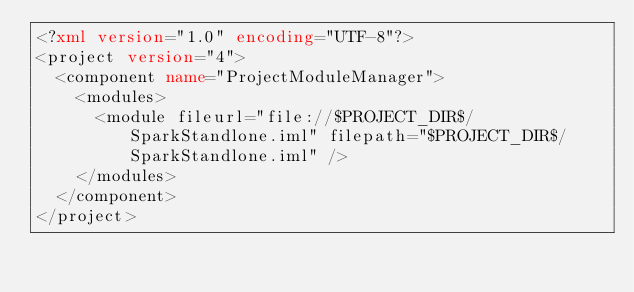Convert code to text. <code><loc_0><loc_0><loc_500><loc_500><_XML_><?xml version="1.0" encoding="UTF-8"?>
<project version="4">
  <component name="ProjectModuleManager">
    <modules>
      <module fileurl="file://$PROJECT_DIR$/SparkStandlone.iml" filepath="$PROJECT_DIR$/SparkStandlone.iml" />
    </modules>
  </component>
</project></code> 